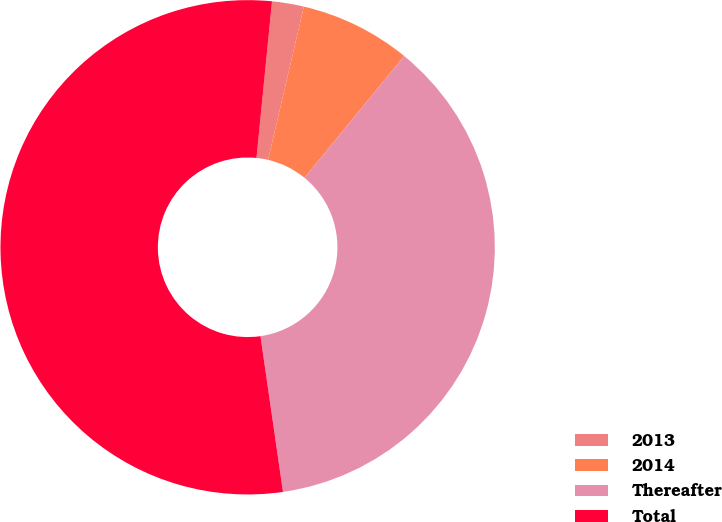Convert chart to OTSL. <chart><loc_0><loc_0><loc_500><loc_500><pie_chart><fcel>2013<fcel>2014<fcel>Thereafter<fcel>Total<nl><fcel>2.08%<fcel>7.26%<fcel>36.8%<fcel>53.85%<nl></chart> 